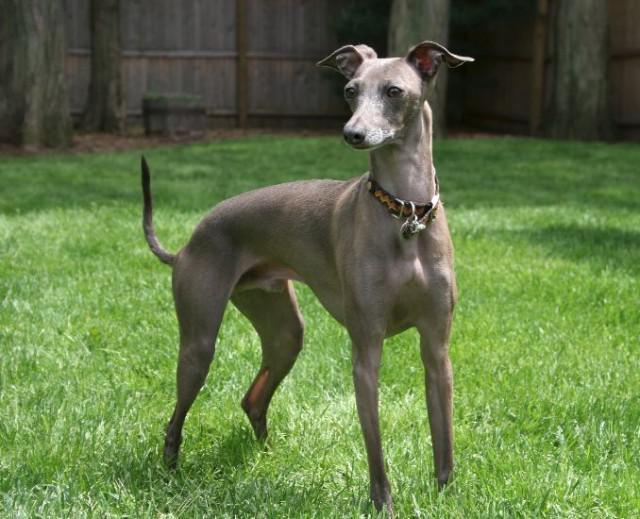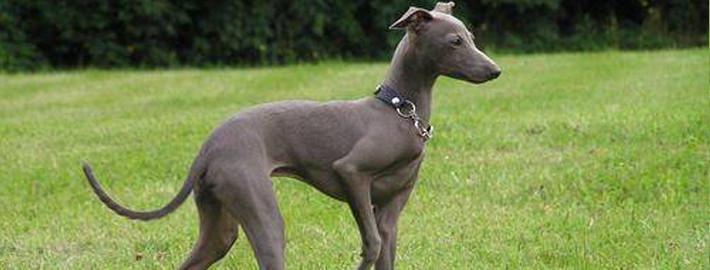The first image is the image on the left, the second image is the image on the right. Evaluate the accuracy of this statement regarding the images: "At least one image shows a grey dog wearing a color.". Is it true? Answer yes or no. Yes. 